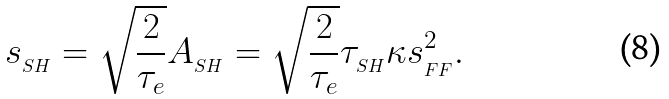Convert formula to latex. <formula><loc_0><loc_0><loc_500><loc_500>s _ { _ { S H } } = \sqrt { \frac { 2 } { \tau _ { e } } } A _ { _ { S H } } = \sqrt { \frac { 2 } { \tau _ { e } } } \tau _ { _ { S H } } \kappa s _ { _ { F F } } ^ { 2 } .</formula> 